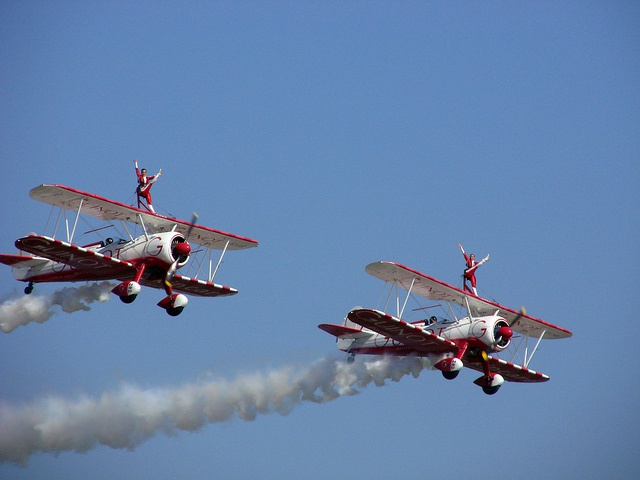Describe the objects in this image and their specific colors. I can see airplane in blue, black, gray, and darkgray tones, airplane in blue, black, gray, and darkgray tones, people in blue, black, maroon, brown, and lightgray tones, people in blue, gray, maroon, lightgray, and brown tones, and people in blue, black, maroon, navy, and gray tones in this image. 